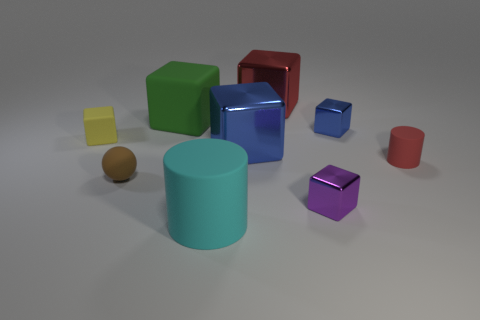How is the lighting affecting the appearance of the objects? The lighting in the image seems to be diffuse, softly illuminating the surfaces of the objects and creating gentle shadows on the ground. This gives the objects a three-dimensional feel and emphasizes their colors without harsh reflections. Are there any reflections on the objects that tell us more about the light source? Yes, we can see soft reflections on some of the objects, particularly on the larger ones, which suggests that there may be a broad light source overhead, providing uniform illumination without strong directional highlights. 